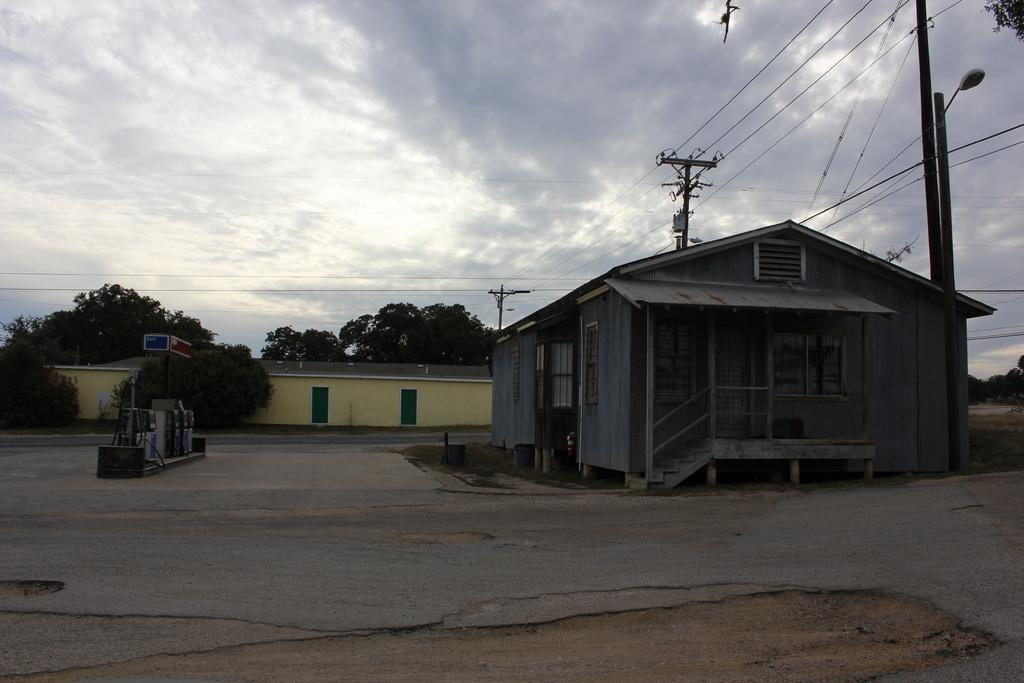What type of structures can be seen in the image? There are houses in the image. What type of vegetation is present in the image? There are trees in the image. What are the poles and wires used for in the image? The poles and wires are likely used for supporting and transmitting electricity or communication signals. What can be found on the houses in the image? There are lights and boards visible on the houses. What type of openings can be seen on the houses? There are doors in the image. What else can be seen in the image besides the mentioned objects? There are other objects in the image, but their specific details are not mentioned in the provided facts. What is visible in the background of the image? The sky is visible in the background of the image, and there are clouds in the sky. What type of straw is being used to read the book in the image? There is no straw or book present in the image. How many ears can be seen on the houses in the image? Houses do not have ears; the question is not applicable to the image. 